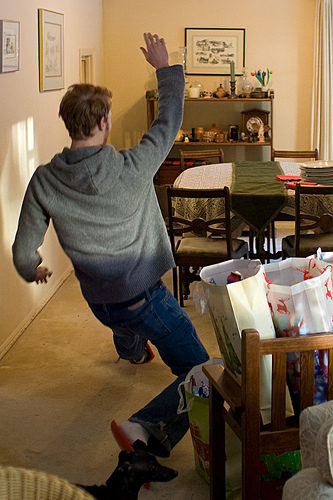<image>
Can you confirm if the man is behind the dog? Yes. From this viewpoint, the man is positioned behind the dog, with the dog partially or fully occluding the man. 